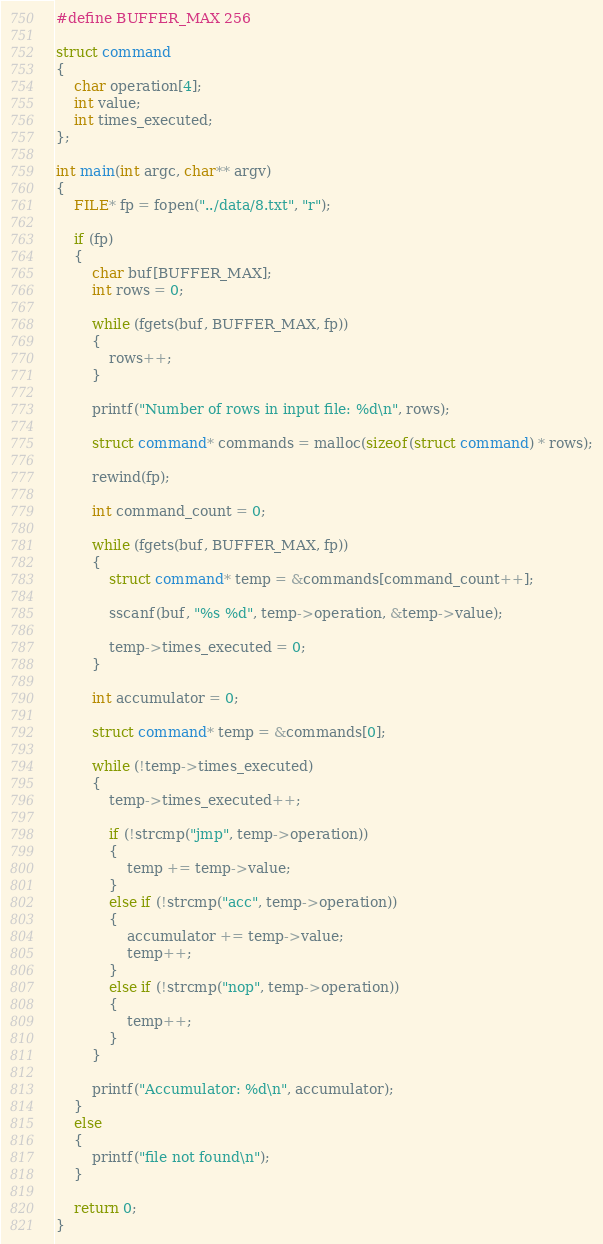<code> <loc_0><loc_0><loc_500><loc_500><_C_>
#define BUFFER_MAX 256

struct command
{
    char operation[4];
    int value;
    int times_executed;
};

int main(int argc, char** argv)
{
    FILE* fp = fopen("../data/8.txt", "r");

    if (fp)
    {
        char buf[BUFFER_MAX];
        int rows = 0;

        while (fgets(buf, BUFFER_MAX, fp))
        {
            rows++;
        }

        printf("Number of rows in input file: %d\n", rows);

        struct command* commands = malloc(sizeof(struct command) * rows);

        rewind(fp);

        int command_count = 0;

        while (fgets(buf, BUFFER_MAX, fp))
        {
            struct command* temp = &commands[command_count++];

            sscanf(buf, "%s %d", temp->operation, &temp->value);

            temp->times_executed = 0;
        }

        int accumulator = 0;

        struct command* temp = &commands[0];

        while (!temp->times_executed)
        {
            temp->times_executed++;

            if (!strcmp("jmp", temp->operation))
            {
                temp += temp->value;    
            }
            else if (!strcmp("acc", temp->operation))
            {
                accumulator += temp->value;
                temp++;
            }
            else if (!strcmp("nop", temp->operation))
            {
                temp++;
            }
        }

        printf("Accumulator: %d\n", accumulator);
    }
    else
    {
        printf("file not found\n");
    }

    return 0;
}</code> 